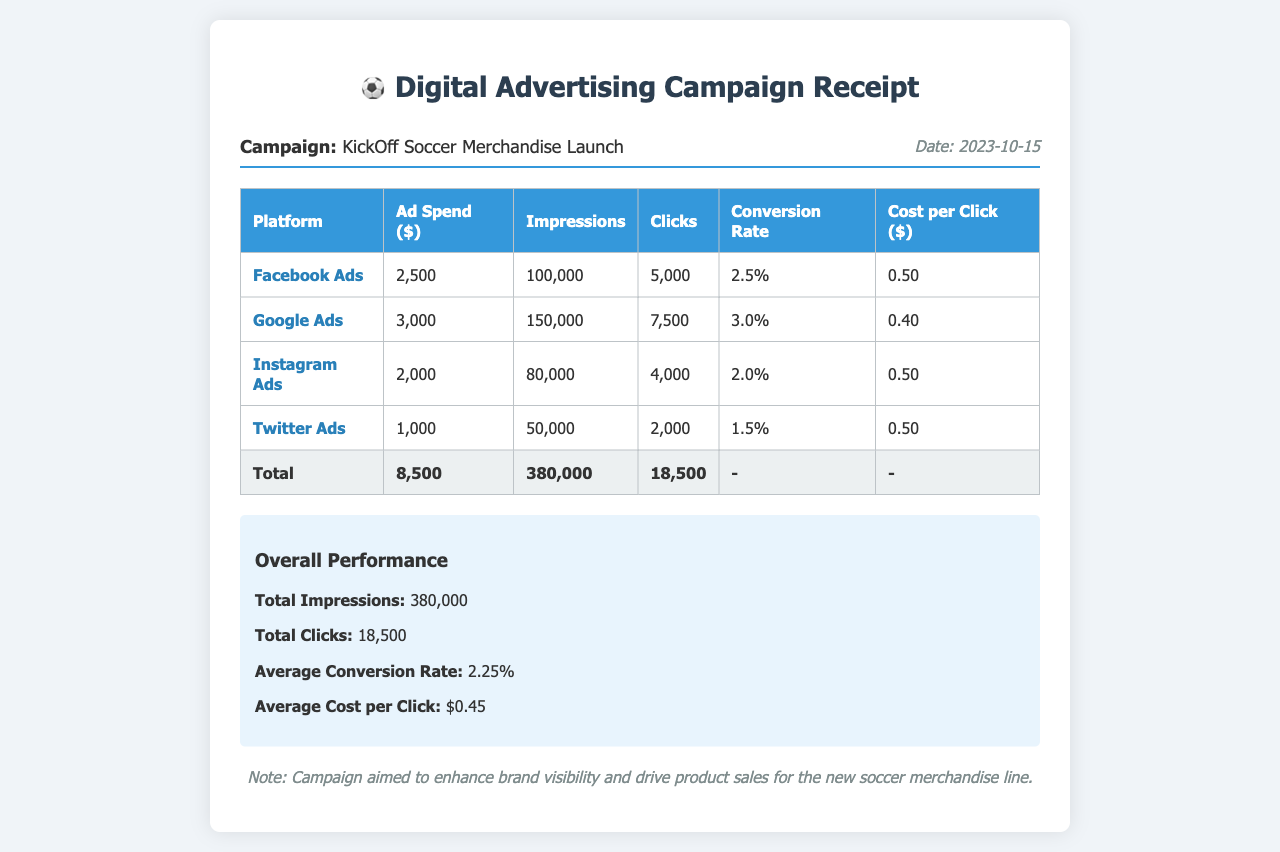What is the date of the campaign? The date of the campaign is provided in the document as 2023-10-15.
Answer: 2023-10-15 What is the ad spend for Google Ads? The ad spend for Google Ads is explicitly mentioned in the table as $3,000.
Answer: $3,000 How many total impressions were recorded? Total impressions are calculated by summing the impressions from all platforms, which totals 380,000.
Answer: 380,000 What is the average conversion rate? The average conversion rate is detailed in the overall performance section as 2.25%.
Answer: 2.25% Which platform had the highest number of clicks? By examining the clicks for each platform, Google Ads had the highest number of clicks with 7,500.
Answer: Google Ads What is the total ad spend across all platforms? The total ad spend is the sum of all ad spends listed, which is $8,500.
Answer: $8,500 Which advertising platform had the lowest spend? The lowest ad spend listed in the table is for Twitter Ads, which spent $1,000.
Answer: Twitter Ads What is the cost per click for the Facebook Ads? The cost per click for Facebook Ads is specified in the table as $0.50.
Answer: $0.50 What is the main aim of the campaign? The aim of the campaign is summarized in the note section as enhancing brand visibility and driving product sales for the new soccer merchandise line.
Answer: Enhance brand visibility and drive product sales 